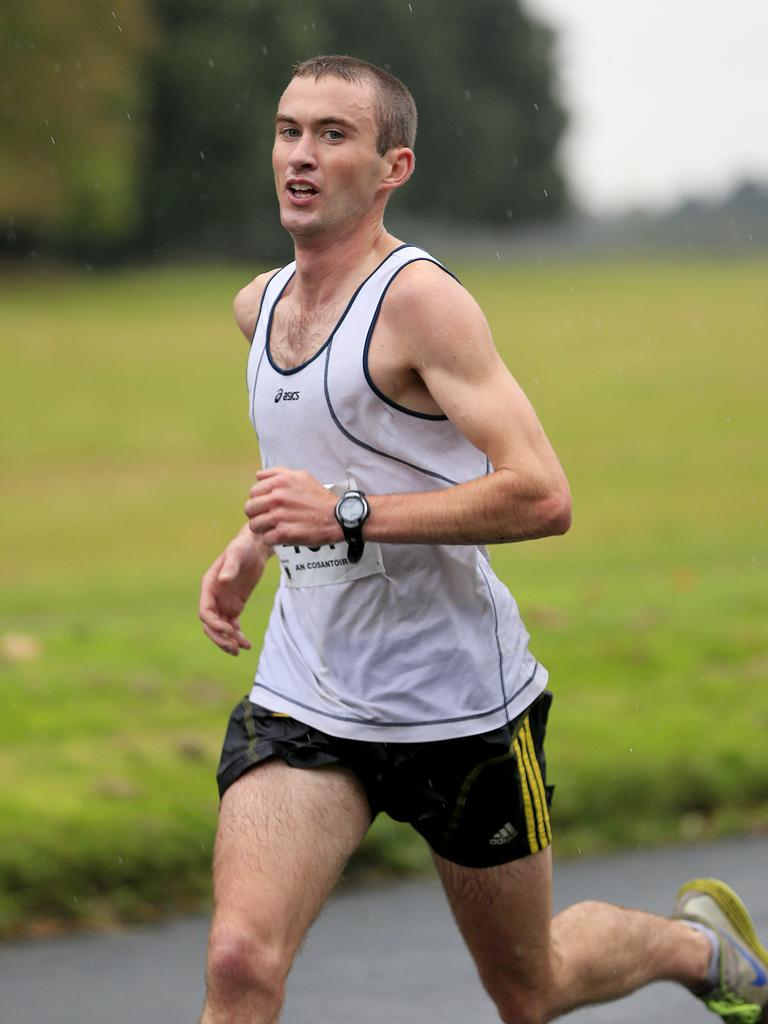<image>
Give a short and clear explanation of the subsequent image. a man running with the word Adidas on his shorts 